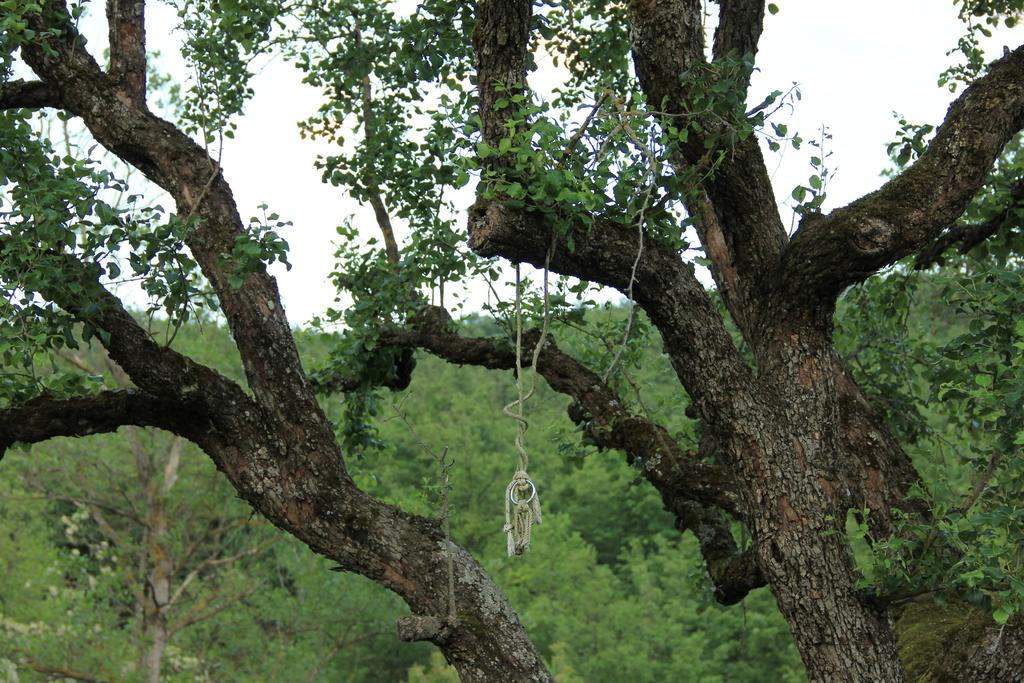What type of vegetation can be seen in the image? There are branches and leaves in the image. What can be seen in the background of the image? There are trees and the sky visible in the background of the image. What type of drain system can be seen in the image? There is no drain system present in the image; it features branches, leaves, trees, and the sky. What is the weight of the leaves in the image? It is not possible to determine the weight of the leaves in the image, as the image does not provide any information about their size or density. 